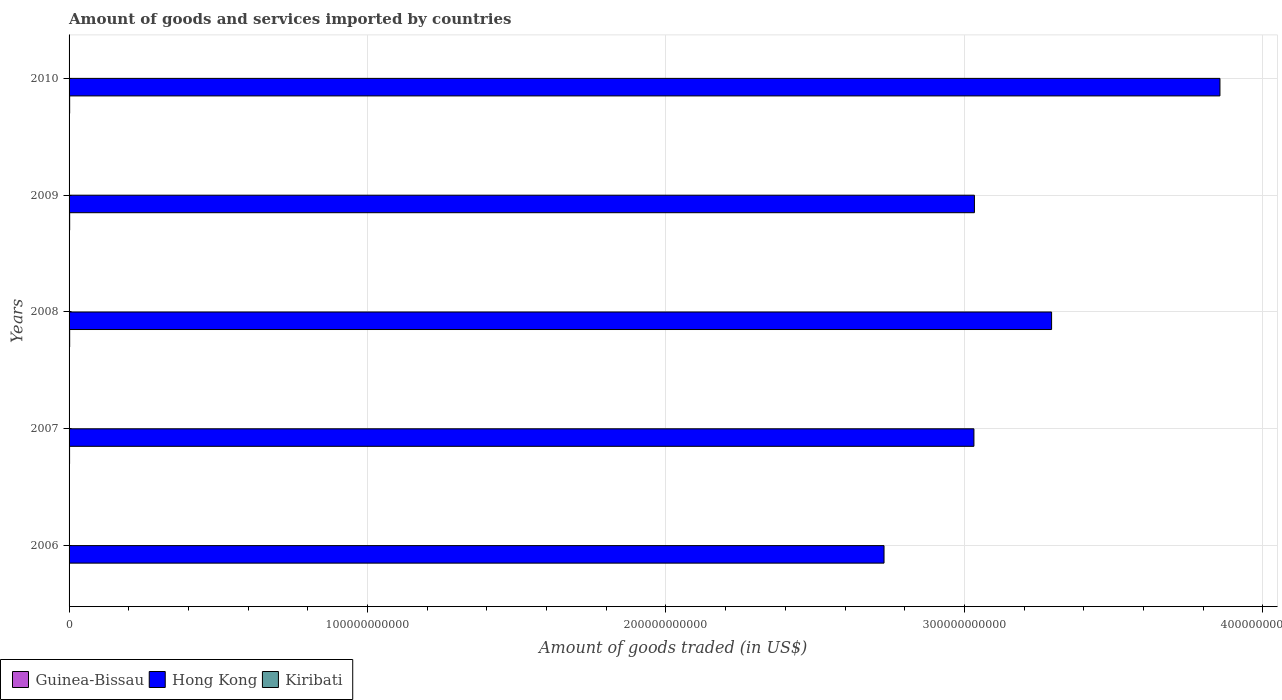How many different coloured bars are there?
Make the answer very short. 3. How many groups of bars are there?
Give a very brief answer. 5. Are the number of bars per tick equal to the number of legend labels?
Keep it short and to the point. Yes. How many bars are there on the 5th tick from the top?
Your response must be concise. 3. What is the label of the 3rd group of bars from the top?
Offer a very short reply. 2008. In how many cases, is the number of bars for a given year not equal to the number of legend labels?
Provide a succinct answer. 0. What is the total amount of goods and services imported in Kiribati in 2010?
Make the answer very short. 7.00e+07. Across all years, what is the maximum total amount of goods and services imported in Hong Kong?
Offer a very short reply. 3.86e+11. Across all years, what is the minimum total amount of goods and services imported in Hong Kong?
Offer a very short reply. 2.73e+11. In which year was the total amount of goods and services imported in Guinea-Bissau maximum?
Your response must be concise. 2009. In which year was the total amount of goods and services imported in Hong Kong minimum?
Your answer should be very brief. 2006. What is the total total amount of goods and services imported in Guinea-Bissau in the graph?
Your answer should be compact. 8.93e+08. What is the difference between the total amount of goods and services imported in Hong Kong in 2008 and that in 2010?
Make the answer very short. -5.64e+1. What is the difference between the total amount of goods and services imported in Hong Kong in 2010 and the total amount of goods and services imported in Guinea-Bissau in 2007?
Your answer should be compact. 3.85e+11. What is the average total amount of goods and services imported in Hong Kong per year?
Offer a very short reply. 3.19e+11. In the year 2010, what is the difference between the total amount of goods and services imported in Kiribati and total amount of goods and services imported in Guinea-Bissau?
Provide a succinct answer. -1.27e+08. In how many years, is the total amount of goods and services imported in Hong Kong greater than 300000000000 US$?
Give a very brief answer. 4. What is the ratio of the total amount of goods and services imported in Hong Kong in 2006 to that in 2008?
Your answer should be compact. 0.83. Is the difference between the total amount of goods and services imported in Kiribati in 2006 and 2009 greater than the difference between the total amount of goods and services imported in Guinea-Bissau in 2006 and 2009?
Keep it short and to the point. Yes. What is the difference between the highest and the second highest total amount of goods and services imported in Guinea-Bissau?
Give a very brief answer. 3.53e+06. What is the difference between the highest and the lowest total amount of goods and services imported in Hong Kong?
Keep it short and to the point. 1.13e+11. What does the 2nd bar from the top in 2009 represents?
Make the answer very short. Hong Kong. What does the 2nd bar from the bottom in 2010 represents?
Make the answer very short. Hong Kong. Is it the case that in every year, the sum of the total amount of goods and services imported in Kiribati and total amount of goods and services imported in Guinea-Bissau is greater than the total amount of goods and services imported in Hong Kong?
Make the answer very short. No. How many bars are there?
Offer a very short reply. 15. Are all the bars in the graph horizontal?
Provide a succinct answer. Yes. How many years are there in the graph?
Provide a succinct answer. 5. What is the difference between two consecutive major ticks on the X-axis?
Offer a very short reply. 1.00e+11. Where does the legend appear in the graph?
Give a very brief answer. Bottom left. What is the title of the graph?
Give a very brief answer. Amount of goods and services imported by countries. Does "Poland" appear as one of the legend labels in the graph?
Your response must be concise. No. What is the label or title of the X-axis?
Give a very brief answer. Amount of goods traded (in US$). What is the Amount of goods traded (in US$) in Guinea-Bissau in 2006?
Offer a terse response. 1.27e+08. What is the Amount of goods traded (in US$) of Hong Kong in 2006?
Make the answer very short. 2.73e+11. What is the Amount of goods traded (in US$) in Kiribati in 2006?
Your answer should be compact. 5.82e+07. What is the Amount of goods traded (in US$) of Guinea-Bissau in 2007?
Your answer should be very brief. 1.68e+08. What is the Amount of goods traded (in US$) of Hong Kong in 2007?
Give a very brief answer. 3.03e+11. What is the Amount of goods traded (in US$) in Kiribati in 2007?
Your answer should be compact. 6.56e+07. What is the Amount of goods traded (in US$) in Guinea-Bissau in 2008?
Give a very brief answer. 1.99e+08. What is the Amount of goods traded (in US$) of Hong Kong in 2008?
Keep it short and to the point. 3.29e+11. What is the Amount of goods traded (in US$) of Kiribati in 2008?
Your response must be concise. 6.96e+07. What is the Amount of goods traded (in US$) of Guinea-Bissau in 2009?
Offer a terse response. 2.02e+08. What is the Amount of goods traded (in US$) of Hong Kong in 2009?
Make the answer very short. 3.03e+11. What is the Amount of goods traded (in US$) in Kiribati in 2009?
Offer a terse response. 6.45e+07. What is the Amount of goods traded (in US$) of Guinea-Bissau in 2010?
Your response must be concise. 1.97e+08. What is the Amount of goods traded (in US$) of Hong Kong in 2010?
Provide a short and direct response. 3.86e+11. What is the Amount of goods traded (in US$) of Kiribati in 2010?
Offer a terse response. 7.00e+07. Across all years, what is the maximum Amount of goods traded (in US$) in Guinea-Bissau?
Offer a terse response. 2.02e+08. Across all years, what is the maximum Amount of goods traded (in US$) of Hong Kong?
Provide a short and direct response. 3.86e+11. Across all years, what is the maximum Amount of goods traded (in US$) of Kiribati?
Offer a very short reply. 7.00e+07. Across all years, what is the minimum Amount of goods traded (in US$) of Guinea-Bissau?
Provide a succinct answer. 1.27e+08. Across all years, what is the minimum Amount of goods traded (in US$) of Hong Kong?
Offer a terse response. 2.73e+11. Across all years, what is the minimum Amount of goods traded (in US$) of Kiribati?
Keep it short and to the point. 5.82e+07. What is the total Amount of goods traded (in US$) in Guinea-Bissau in the graph?
Offer a very short reply. 8.93e+08. What is the total Amount of goods traded (in US$) of Hong Kong in the graph?
Provide a succinct answer. 1.59e+12. What is the total Amount of goods traded (in US$) in Kiribati in the graph?
Provide a short and direct response. 3.28e+08. What is the difference between the Amount of goods traded (in US$) in Guinea-Bissau in 2006 and that in 2007?
Offer a terse response. -4.09e+07. What is the difference between the Amount of goods traded (in US$) of Hong Kong in 2006 and that in 2007?
Your answer should be compact. -3.01e+1. What is the difference between the Amount of goods traded (in US$) in Kiribati in 2006 and that in 2007?
Provide a succinct answer. -7.38e+06. What is the difference between the Amount of goods traded (in US$) of Guinea-Bissau in 2006 and that in 2008?
Make the answer very short. -7.17e+07. What is the difference between the Amount of goods traded (in US$) in Hong Kong in 2006 and that in 2008?
Ensure brevity in your answer.  -5.61e+1. What is the difference between the Amount of goods traded (in US$) in Kiribati in 2006 and that in 2008?
Offer a terse response. -1.13e+07. What is the difference between the Amount of goods traded (in US$) in Guinea-Bissau in 2006 and that in 2009?
Your answer should be compact. -7.53e+07. What is the difference between the Amount of goods traded (in US$) in Hong Kong in 2006 and that in 2009?
Offer a very short reply. -3.03e+1. What is the difference between the Amount of goods traded (in US$) in Kiribati in 2006 and that in 2009?
Give a very brief answer. -6.29e+06. What is the difference between the Amount of goods traded (in US$) in Guinea-Bissau in 2006 and that in 2010?
Offer a very short reply. -6.95e+07. What is the difference between the Amount of goods traded (in US$) in Hong Kong in 2006 and that in 2010?
Your answer should be compact. -1.13e+11. What is the difference between the Amount of goods traded (in US$) of Kiribati in 2006 and that in 2010?
Your response must be concise. -1.18e+07. What is the difference between the Amount of goods traded (in US$) in Guinea-Bissau in 2007 and that in 2008?
Your answer should be very brief. -3.09e+07. What is the difference between the Amount of goods traded (in US$) in Hong Kong in 2007 and that in 2008?
Offer a very short reply. -2.60e+1. What is the difference between the Amount of goods traded (in US$) in Kiribati in 2007 and that in 2008?
Give a very brief answer. -3.96e+06. What is the difference between the Amount of goods traded (in US$) in Guinea-Bissau in 2007 and that in 2009?
Ensure brevity in your answer.  -3.44e+07. What is the difference between the Amount of goods traded (in US$) of Hong Kong in 2007 and that in 2009?
Your answer should be compact. -1.67e+08. What is the difference between the Amount of goods traded (in US$) in Kiribati in 2007 and that in 2009?
Your answer should be very brief. 1.09e+06. What is the difference between the Amount of goods traded (in US$) of Guinea-Bissau in 2007 and that in 2010?
Offer a terse response. -2.87e+07. What is the difference between the Amount of goods traded (in US$) in Hong Kong in 2007 and that in 2010?
Offer a very short reply. -8.24e+1. What is the difference between the Amount of goods traded (in US$) of Kiribati in 2007 and that in 2010?
Make the answer very short. -4.37e+06. What is the difference between the Amount of goods traded (in US$) in Guinea-Bissau in 2008 and that in 2009?
Offer a terse response. -3.53e+06. What is the difference between the Amount of goods traded (in US$) in Hong Kong in 2008 and that in 2009?
Keep it short and to the point. 2.59e+1. What is the difference between the Amount of goods traded (in US$) in Kiribati in 2008 and that in 2009?
Offer a terse response. 5.06e+06. What is the difference between the Amount of goods traded (in US$) of Guinea-Bissau in 2008 and that in 2010?
Your answer should be very brief. 2.22e+06. What is the difference between the Amount of goods traded (in US$) in Hong Kong in 2008 and that in 2010?
Ensure brevity in your answer.  -5.64e+1. What is the difference between the Amount of goods traded (in US$) in Kiribati in 2008 and that in 2010?
Offer a very short reply. -4.12e+05. What is the difference between the Amount of goods traded (in US$) in Guinea-Bissau in 2009 and that in 2010?
Keep it short and to the point. 5.75e+06. What is the difference between the Amount of goods traded (in US$) of Hong Kong in 2009 and that in 2010?
Keep it short and to the point. -8.23e+1. What is the difference between the Amount of goods traded (in US$) of Kiribati in 2009 and that in 2010?
Make the answer very short. -5.47e+06. What is the difference between the Amount of goods traded (in US$) of Guinea-Bissau in 2006 and the Amount of goods traded (in US$) of Hong Kong in 2007?
Offer a terse response. -3.03e+11. What is the difference between the Amount of goods traded (in US$) of Guinea-Bissau in 2006 and the Amount of goods traded (in US$) of Kiribati in 2007?
Your response must be concise. 6.14e+07. What is the difference between the Amount of goods traded (in US$) of Hong Kong in 2006 and the Amount of goods traded (in US$) of Kiribati in 2007?
Your answer should be very brief. 2.73e+11. What is the difference between the Amount of goods traded (in US$) in Guinea-Bissau in 2006 and the Amount of goods traded (in US$) in Hong Kong in 2008?
Your answer should be compact. -3.29e+11. What is the difference between the Amount of goods traded (in US$) of Guinea-Bissau in 2006 and the Amount of goods traded (in US$) of Kiribati in 2008?
Offer a very short reply. 5.75e+07. What is the difference between the Amount of goods traded (in US$) of Hong Kong in 2006 and the Amount of goods traded (in US$) of Kiribati in 2008?
Offer a very short reply. 2.73e+11. What is the difference between the Amount of goods traded (in US$) in Guinea-Bissau in 2006 and the Amount of goods traded (in US$) in Hong Kong in 2009?
Keep it short and to the point. -3.03e+11. What is the difference between the Amount of goods traded (in US$) of Guinea-Bissau in 2006 and the Amount of goods traded (in US$) of Kiribati in 2009?
Provide a succinct answer. 6.25e+07. What is the difference between the Amount of goods traded (in US$) in Hong Kong in 2006 and the Amount of goods traded (in US$) in Kiribati in 2009?
Your answer should be very brief. 2.73e+11. What is the difference between the Amount of goods traded (in US$) of Guinea-Bissau in 2006 and the Amount of goods traded (in US$) of Hong Kong in 2010?
Your answer should be very brief. -3.85e+11. What is the difference between the Amount of goods traded (in US$) in Guinea-Bissau in 2006 and the Amount of goods traded (in US$) in Kiribati in 2010?
Give a very brief answer. 5.71e+07. What is the difference between the Amount of goods traded (in US$) of Hong Kong in 2006 and the Amount of goods traded (in US$) of Kiribati in 2010?
Provide a succinct answer. 2.73e+11. What is the difference between the Amount of goods traded (in US$) of Guinea-Bissau in 2007 and the Amount of goods traded (in US$) of Hong Kong in 2008?
Your answer should be very brief. -3.29e+11. What is the difference between the Amount of goods traded (in US$) in Guinea-Bissau in 2007 and the Amount of goods traded (in US$) in Kiribati in 2008?
Your answer should be compact. 9.83e+07. What is the difference between the Amount of goods traded (in US$) in Hong Kong in 2007 and the Amount of goods traded (in US$) in Kiribati in 2008?
Provide a succinct answer. 3.03e+11. What is the difference between the Amount of goods traded (in US$) of Guinea-Bissau in 2007 and the Amount of goods traded (in US$) of Hong Kong in 2009?
Give a very brief answer. -3.03e+11. What is the difference between the Amount of goods traded (in US$) in Guinea-Bissau in 2007 and the Amount of goods traded (in US$) in Kiribati in 2009?
Offer a very short reply. 1.03e+08. What is the difference between the Amount of goods traded (in US$) in Hong Kong in 2007 and the Amount of goods traded (in US$) in Kiribati in 2009?
Ensure brevity in your answer.  3.03e+11. What is the difference between the Amount of goods traded (in US$) of Guinea-Bissau in 2007 and the Amount of goods traded (in US$) of Hong Kong in 2010?
Your response must be concise. -3.85e+11. What is the difference between the Amount of goods traded (in US$) of Guinea-Bissau in 2007 and the Amount of goods traded (in US$) of Kiribati in 2010?
Give a very brief answer. 9.79e+07. What is the difference between the Amount of goods traded (in US$) of Hong Kong in 2007 and the Amount of goods traded (in US$) of Kiribati in 2010?
Offer a terse response. 3.03e+11. What is the difference between the Amount of goods traded (in US$) in Guinea-Bissau in 2008 and the Amount of goods traded (in US$) in Hong Kong in 2009?
Give a very brief answer. -3.03e+11. What is the difference between the Amount of goods traded (in US$) in Guinea-Bissau in 2008 and the Amount of goods traded (in US$) in Kiribati in 2009?
Keep it short and to the point. 1.34e+08. What is the difference between the Amount of goods traded (in US$) in Hong Kong in 2008 and the Amount of goods traded (in US$) in Kiribati in 2009?
Offer a terse response. 3.29e+11. What is the difference between the Amount of goods traded (in US$) of Guinea-Bissau in 2008 and the Amount of goods traded (in US$) of Hong Kong in 2010?
Offer a very short reply. -3.85e+11. What is the difference between the Amount of goods traded (in US$) in Guinea-Bissau in 2008 and the Amount of goods traded (in US$) in Kiribati in 2010?
Provide a succinct answer. 1.29e+08. What is the difference between the Amount of goods traded (in US$) of Hong Kong in 2008 and the Amount of goods traded (in US$) of Kiribati in 2010?
Offer a very short reply. 3.29e+11. What is the difference between the Amount of goods traded (in US$) in Guinea-Bissau in 2009 and the Amount of goods traded (in US$) in Hong Kong in 2010?
Offer a very short reply. -3.85e+11. What is the difference between the Amount of goods traded (in US$) in Guinea-Bissau in 2009 and the Amount of goods traded (in US$) in Kiribati in 2010?
Ensure brevity in your answer.  1.32e+08. What is the difference between the Amount of goods traded (in US$) in Hong Kong in 2009 and the Amount of goods traded (in US$) in Kiribati in 2010?
Provide a succinct answer. 3.03e+11. What is the average Amount of goods traded (in US$) of Guinea-Bissau per year?
Your answer should be compact. 1.79e+08. What is the average Amount of goods traded (in US$) in Hong Kong per year?
Give a very brief answer. 3.19e+11. What is the average Amount of goods traded (in US$) in Kiribati per year?
Your response must be concise. 6.56e+07. In the year 2006, what is the difference between the Amount of goods traded (in US$) in Guinea-Bissau and Amount of goods traded (in US$) in Hong Kong?
Offer a terse response. -2.73e+11. In the year 2006, what is the difference between the Amount of goods traded (in US$) of Guinea-Bissau and Amount of goods traded (in US$) of Kiribati?
Offer a very short reply. 6.88e+07. In the year 2006, what is the difference between the Amount of goods traded (in US$) in Hong Kong and Amount of goods traded (in US$) in Kiribati?
Give a very brief answer. 2.73e+11. In the year 2007, what is the difference between the Amount of goods traded (in US$) in Guinea-Bissau and Amount of goods traded (in US$) in Hong Kong?
Ensure brevity in your answer.  -3.03e+11. In the year 2007, what is the difference between the Amount of goods traded (in US$) in Guinea-Bissau and Amount of goods traded (in US$) in Kiribati?
Provide a succinct answer. 1.02e+08. In the year 2007, what is the difference between the Amount of goods traded (in US$) in Hong Kong and Amount of goods traded (in US$) in Kiribati?
Keep it short and to the point. 3.03e+11. In the year 2008, what is the difference between the Amount of goods traded (in US$) of Guinea-Bissau and Amount of goods traded (in US$) of Hong Kong?
Provide a succinct answer. -3.29e+11. In the year 2008, what is the difference between the Amount of goods traded (in US$) in Guinea-Bissau and Amount of goods traded (in US$) in Kiribati?
Give a very brief answer. 1.29e+08. In the year 2008, what is the difference between the Amount of goods traded (in US$) of Hong Kong and Amount of goods traded (in US$) of Kiribati?
Provide a short and direct response. 3.29e+11. In the year 2009, what is the difference between the Amount of goods traded (in US$) in Guinea-Bissau and Amount of goods traded (in US$) in Hong Kong?
Keep it short and to the point. -3.03e+11. In the year 2009, what is the difference between the Amount of goods traded (in US$) in Guinea-Bissau and Amount of goods traded (in US$) in Kiribati?
Your answer should be compact. 1.38e+08. In the year 2009, what is the difference between the Amount of goods traded (in US$) of Hong Kong and Amount of goods traded (in US$) of Kiribati?
Provide a short and direct response. 3.03e+11. In the year 2010, what is the difference between the Amount of goods traded (in US$) of Guinea-Bissau and Amount of goods traded (in US$) of Hong Kong?
Your answer should be very brief. -3.85e+11. In the year 2010, what is the difference between the Amount of goods traded (in US$) of Guinea-Bissau and Amount of goods traded (in US$) of Kiribati?
Offer a terse response. 1.27e+08. In the year 2010, what is the difference between the Amount of goods traded (in US$) of Hong Kong and Amount of goods traded (in US$) of Kiribati?
Offer a very short reply. 3.86e+11. What is the ratio of the Amount of goods traded (in US$) in Guinea-Bissau in 2006 to that in 2007?
Provide a succinct answer. 0.76. What is the ratio of the Amount of goods traded (in US$) in Hong Kong in 2006 to that in 2007?
Make the answer very short. 0.9. What is the ratio of the Amount of goods traded (in US$) of Kiribati in 2006 to that in 2007?
Provide a short and direct response. 0.89. What is the ratio of the Amount of goods traded (in US$) of Guinea-Bissau in 2006 to that in 2008?
Your response must be concise. 0.64. What is the ratio of the Amount of goods traded (in US$) of Hong Kong in 2006 to that in 2008?
Give a very brief answer. 0.83. What is the ratio of the Amount of goods traded (in US$) in Kiribati in 2006 to that in 2008?
Keep it short and to the point. 0.84. What is the ratio of the Amount of goods traded (in US$) of Guinea-Bissau in 2006 to that in 2009?
Offer a terse response. 0.63. What is the ratio of the Amount of goods traded (in US$) of Hong Kong in 2006 to that in 2009?
Provide a short and direct response. 0.9. What is the ratio of the Amount of goods traded (in US$) in Kiribati in 2006 to that in 2009?
Make the answer very short. 0.9. What is the ratio of the Amount of goods traded (in US$) of Guinea-Bissau in 2006 to that in 2010?
Ensure brevity in your answer.  0.65. What is the ratio of the Amount of goods traded (in US$) of Hong Kong in 2006 to that in 2010?
Ensure brevity in your answer.  0.71. What is the ratio of the Amount of goods traded (in US$) of Kiribati in 2006 to that in 2010?
Your answer should be very brief. 0.83. What is the ratio of the Amount of goods traded (in US$) of Guinea-Bissau in 2007 to that in 2008?
Offer a terse response. 0.84. What is the ratio of the Amount of goods traded (in US$) in Hong Kong in 2007 to that in 2008?
Provide a short and direct response. 0.92. What is the ratio of the Amount of goods traded (in US$) of Kiribati in 2007 to that in 2008?
Make the answer very short. 0.94. What is the ratio of the Amount of goods traded (in US$) in Guinea-Bissau in 2007 to that in 2009?
Your answer should be very brief. 0.83. What is the ratio of the Amount of goods traded (in US$) of Kiribati in 2007 to that in 2009?
Keep it short and to the point. 1.02. What is the ratio of the Amount of goods traded (in US$) in Guinea-Bissau in 2007 to that in 2010?
Your response must be concise. 0.85. What is the ratio of the Amount of goods traded (in US$) in Hong Kong in 2007 to that in 2010?
Your response must be concise. 0.79. What is the ratio of the Amount of goods traded (in US$) of Kiribati in 2007 to that in 2010?
Your response must be concise. 0.94. What is the ratio of the Amount of goods traded (in US$) of Guinea-Bissau in 2008 to that in 2009?
Provide a succinct answer. 0.98. What is the ratio of the Amount of goods traded (in US$) in Hong Kong in 2008 to that in 2009?
Provide a short and direct response. 1.09. What is the ratio of the Amount of goods traded (in US$) in Kiribati in 2008 to that in 2009?
Your answer should be very brief. 1.08. What is the ratio of the Amount of goods traded (in US$) in Guinea-Bissau in 2008 to that in 2010?
Your answer should be compact. 1.01. What is the ratio of the Amount of goods traded (in US$) of Hong Kong in 2008 to that in 2010?
Your answer should be very brief. 0.85. What is the ratio of the Amount of goods traded (in US$) of Kiribati in 2008 to that in 2010?
Your answer should be compact. 0.99. What is the ratio of the Amount of goods traded (in US$) in Guinea-Bissau in 2009 to that in 2010?
Your response must be concise. 1.03. What is the ratio of the Amount of goods traded (in US$) in Hong Kong in 2009 to that in 2010?
Offer a very short reply. 0.79. What is the ratio of the Amount of goods traded (in US$) in Kiribati in 2009 to that in 2010?
Provide a short and direct response. 0.92. What is the difference between the highest and the second highest Amount of goods traded (in US$) in Guinea-Bissau?
Ensure brevity in your answer.  3.53e+06. What is the difference between the highest and the second highest Amount of goods traded (in US$) in Hong Kong?
Offer a very short reply. 5.64e+1. What is the difference between the highest and the second highest Amount of goods traded (in US$) of Kiribati?
Your response must be concise. 4.12e+05. What is the difference between the highest and the lowest Amount of goods traded (in US$) in Guinea-Bissau?
Provide a short and direct response. 7.53e+07. What is the difference between the highest and the lowest Amount of goods traded (in US$) of Hong Kong?
Ensure brevity in your answer.  1.13e+11. What is the difference between the highest and the lowest Amount of goods traded (in US$) of Kiribati?
Offer a terse response. 1.18e+07. 